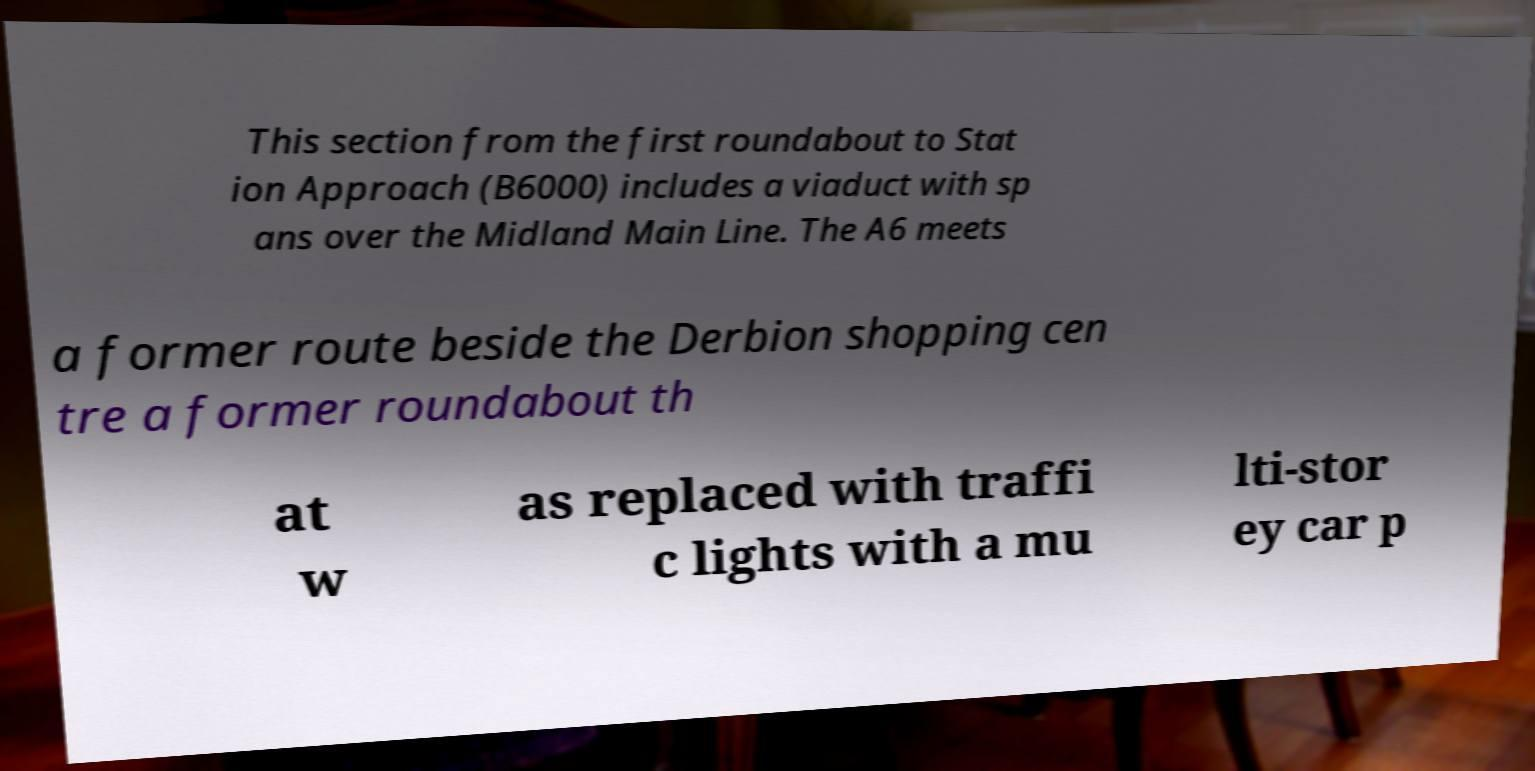For documentation purposes, I need the text within this image transcribed. Could you provide that? This section from the first roundabout to Stat ion Approach (B6000) includes a viaduct with sp ans over the Midland Main Line. The A6 meets a former route beside the Derbion shopping cen tre a former roundabout th at w as replaced with traffi c lights with a mu lti-stor ey car p 